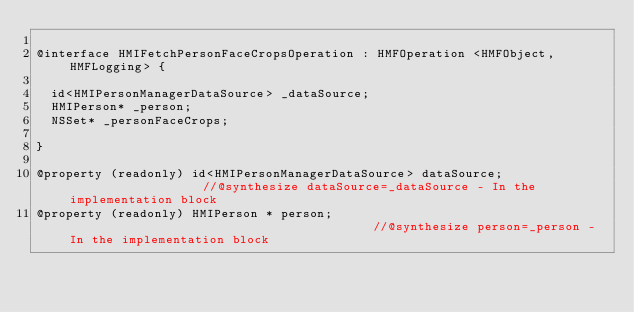Convert code to text. <code><loc_0><loc_0><loc_500><loc_500><_C_>
@interface HMIFetchPersonFaceCropsOperation : HMFOperation <HMFObject, HMFLogging> {

	id<HMIPersonManagerDataSource> _dataSource;
	HMIPerson* _person;
	NSSet* _personFaceCrops;

}

@property (readonly) id<HMIPersonManagerDataSource> dataSource;                   //@synthesize dataSource=_dataSource - In the implementation block
@property (readonly) HMIPerson * person;                                          //@synthesize person=_person - In the implementation block</code> 